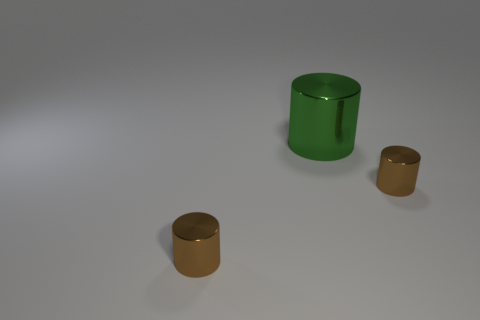Add 3 small cylinders. How many objects exist? 6 Add 3 big green metal cylinders. How many big green metal cylinders exist? 4 Subtract all brown cylinders. How many cylinders are left? 1 Subtract all large green cylinders. How many cylinders are left? 2 Subtract 0 blue balls. How many objects are left? 3 Subtract 1 cylinders. How many cylinders are left? 2 Subtract all brown cylinders. Subtract all gray spheres. How many cylinders are left? 1 Subtract all brown cubes. How many red cylinders are left? 0 Subtract all cylinders. Subtract all cyan balls. How many objects are left? 0 Add 1 brown things. How many brown things are left? 3 